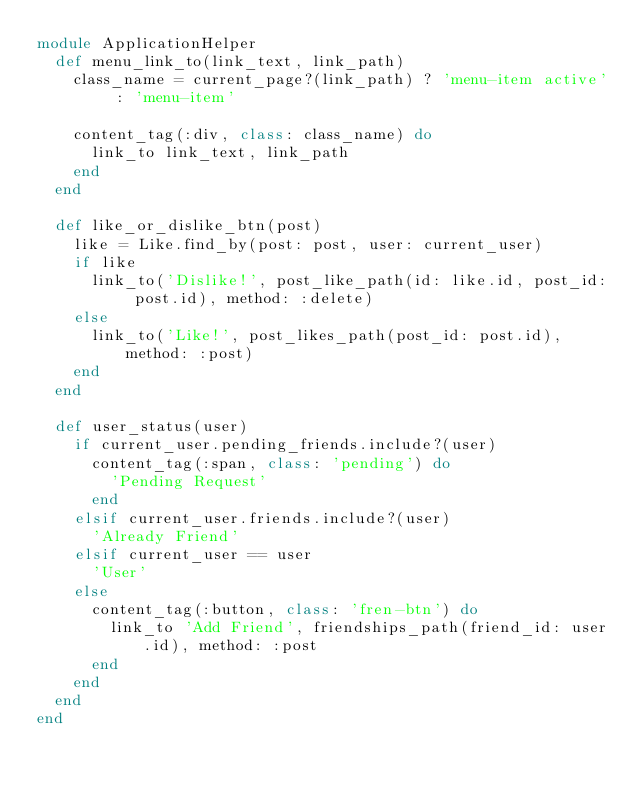Convert code to text. <code><loc_0><loc_0><loc_500><loc_500><_Ruby_>module ApplicationHelper
  def menu_link_to(link_text, link_path)
    class_name = current_page?(link_path) ? 'menu-item active' : 'menu-item'

    content_tag(:div, class: class_name) do
      link_to link_text, link_path
    end
  end

  def like_or_dislike_btn(post)
    like = Like.find_by(post: post, user: current_user)
    if like
      link_to('Dislike!', post_like_path(id: like.id, post_id: post.id), method: :delete)
    else
      link_to('Like!', post_likes_path(post_id: post.id), method: :post)
    end
  end

  def user_status(user)
    if current_user.pending_friends.include?(user)
      content_tag(:span, class: 'pending') do
        'Pending Request'
      end
    elsif current_user.friends.include?(user)
      'Already Friend'
    elsif current_user == user
      'User'
    else
      content_tag(:button, class: 'fren-btn') do
        link_to 'Add Friend', friendships_path(friend_id: user.id), method: :post
      end
    end
  end
end
</code> 